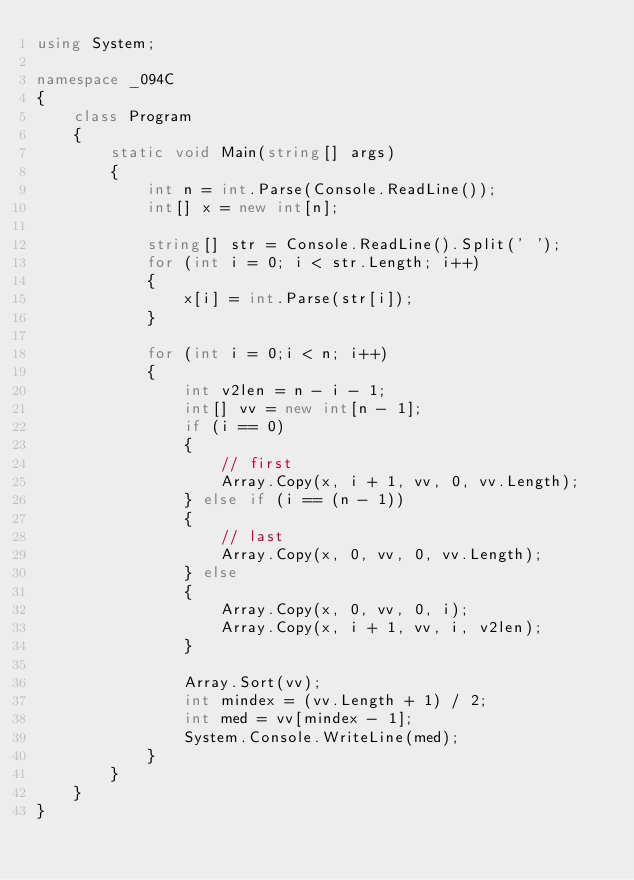Convert code to text. <code><loc_0><loc_0><loc_500><loc_500><_C#_>using System;

namespace _094C
{
    class Program
    {
        static void Main(string[] args)
        {
            int n = int.Parse(Console.ReadLine());
            int[] x = new int[n];

            string[] str = Console.ReadLine().Split(' ');
            for (int i = 0; i < str.Length; i++)
            {
                x[i] = int.Parse(str[i]);
            }

            for (int i = 0;i < n; i++)
            {
                int v2len = n - i - 1;
                int[] vv = new int[n - 1];
                if (i == 0)
                {
                    // first
                    Array.Copy(x, i + 1, vv, 0, vv.Length);
                } else if (i == (n - 1))
                {
                    // last
                    Array.Copy(x, 0, vv, 0, vv.Length);
                } else
                {
                    Array.Copy(x, 0, vv, 0, i);
                    Array.Copy(x, i + 1, vv, i, v2len);
                }

                Array.Sort(vv);
                int mindex = (vv.Length + 1) / 2;
                int med = vv[mindex - 1];
                System.Console.WriteLine(med);
            }
        }
    }
}</code> 